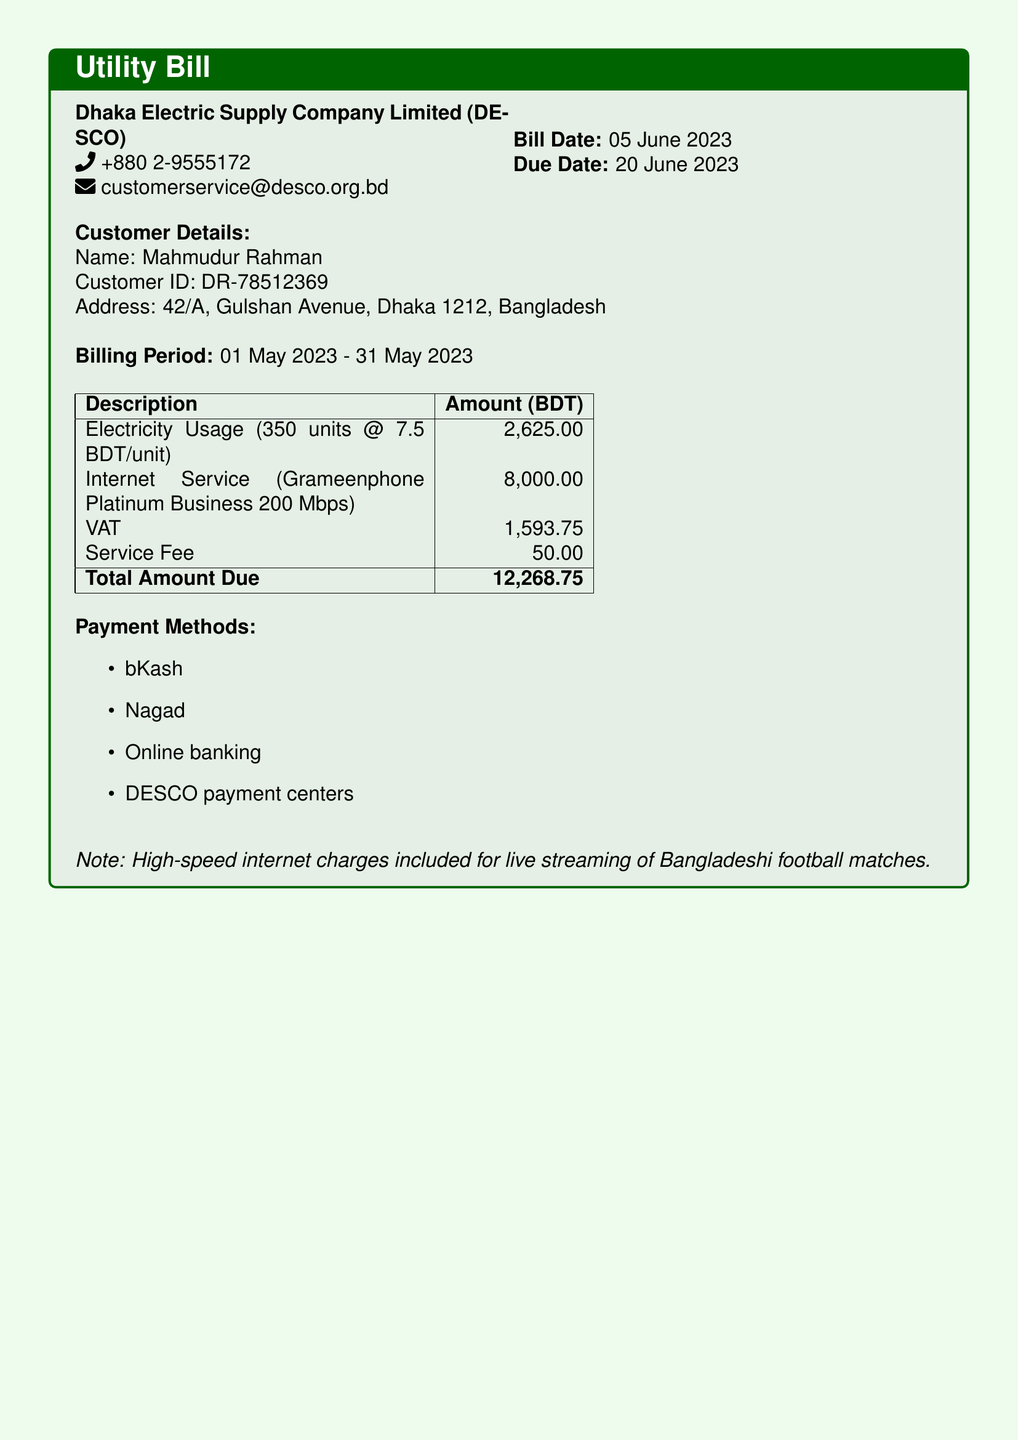What is the bill date? The bill date is clearly stated in the document.
Answer: 05 June 2023 What is the total amount due? The total amount due is listed in the summary table at the end of the bill.
Answer: 12,268.75 What is the electricity usage charge? The electricity usage charge is specified in the description of costs within the document.
Answer: 2,625.00 Who is the customer? The customer details section provides the name of the person responsible for the bill.
Answer: Mahmudur Rahman What is the billing period? The billing period is listed directly under the customer details section.
Answer: 01 May 2023 - 31 May 2023 What is the VAT amount? The VAT amount is included in the list of charges in the document.
Answer: 1,593.75 What internet service provider is mentioned? The document specifies the internet service provider and plan included in the charges section.
Answer: Grameenphone What is the service fee? The service fee is indicated in the detailed charges table provided in the document.
Answer: 50.00 Which payment methods are available? The payment methods are listed at the end of the document.
Answer: bKash, Nagad, Online banking, DESCO payment centers 